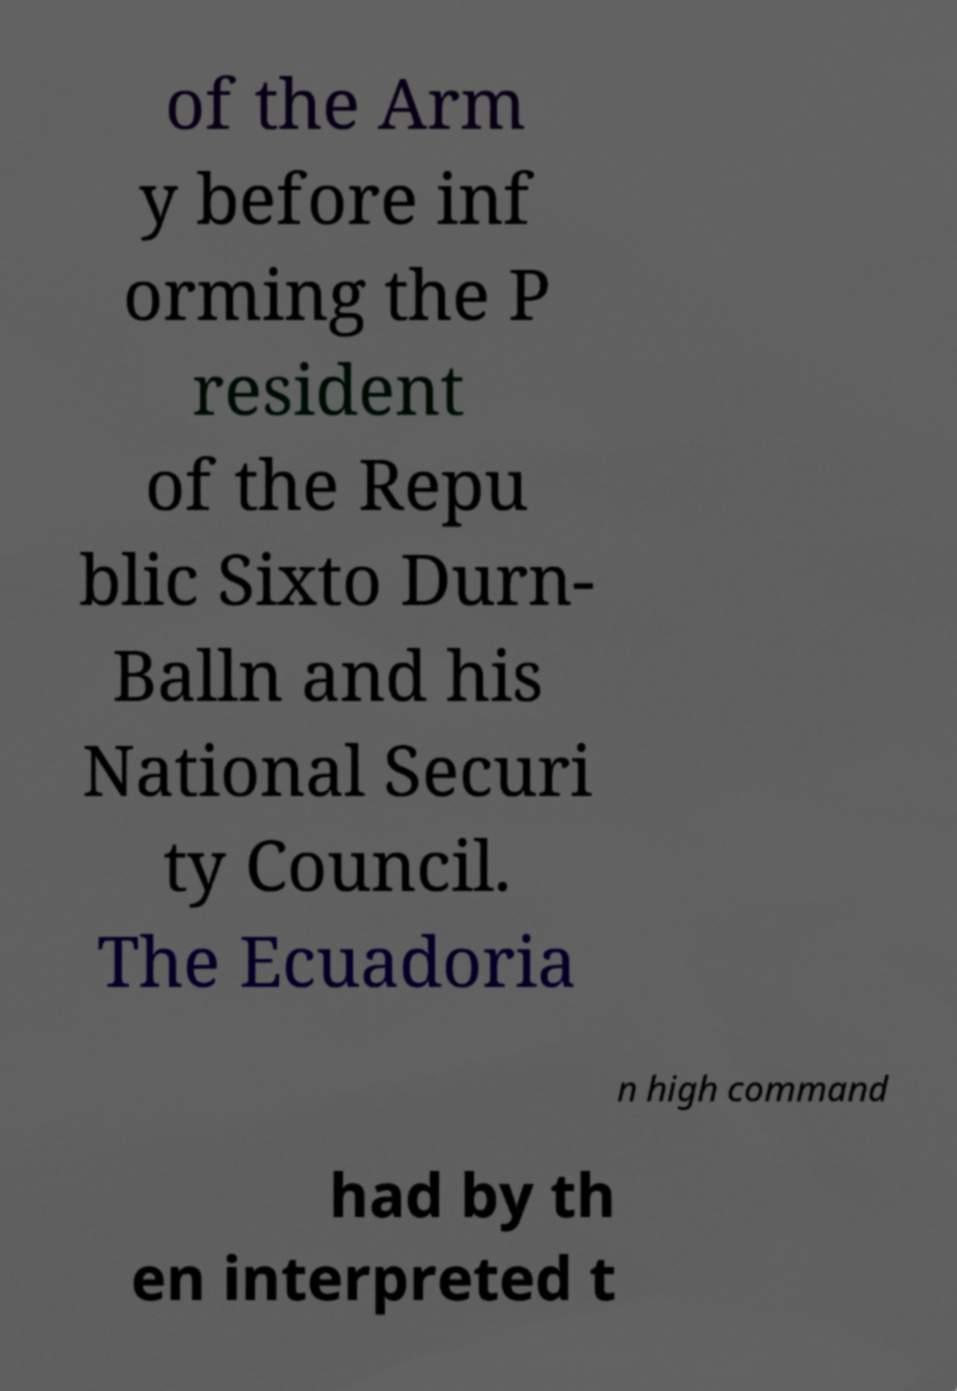There's text embedded in this image that I need extracted. Can you transcribe it verbatim? of the Arm y before inf orming the P resident of the Repu blic Sixto Durn- Balln and his National Securi ty Council. The Ecuadoria n high command had by th en interpreted t 